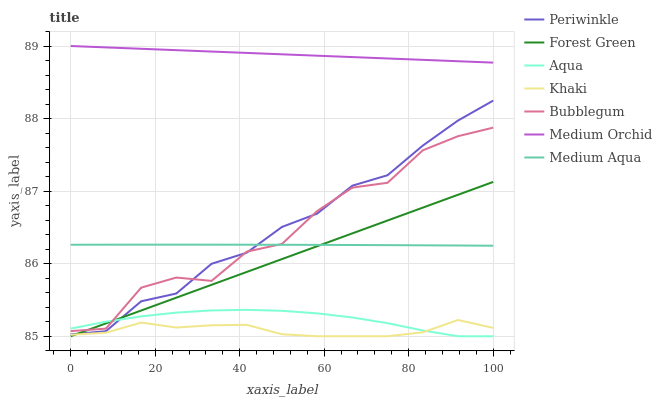Does Khaki have the minimum area under the curve?
Answer yes or no. Yes. Does Medium Orchid have the maximum area under the curve?
Answer yes or no. Yes. Does Aqua have the minimum area under the curve?
Answer yes or no. No. Does Aqua have the maximum area under the curve?
Answer yes or no. No. Is Medium Orchid the smoothest?
Answer yes or no. Yes. Is Bubblegum the roughest?
Answer yes or no. Yes. Is Aqua the smoothest?
Answer yes or no. No. Is Aqua the roughest?
Answer yes or no. No. Does Khaki have the lowest value?
Answer yes or no. Yes. Does Medium Orchid have the lowest value?
Answer yes or no. No. Does Medium Orchid have the highest value?
Answer yes or no. Yes. Does Aqua have the highest value?
Answer yes or no. No. Is Khaki less than Bubblegum?
Answer yes or no. Yes. Is Periwinkle greater than Khaki?
Answer yes or no. Yes. Does Bubblegum intersect Medium Aqua?
Answer yes or no. Yes. Is Bubblegum less than Medium Aqua?
Answer yes or no. No. Is Bubblegum greater than Medium Aqua?
Answer yes or no. No. Does Khaki intersect Bubblegum?
Answer yes or no. No. 